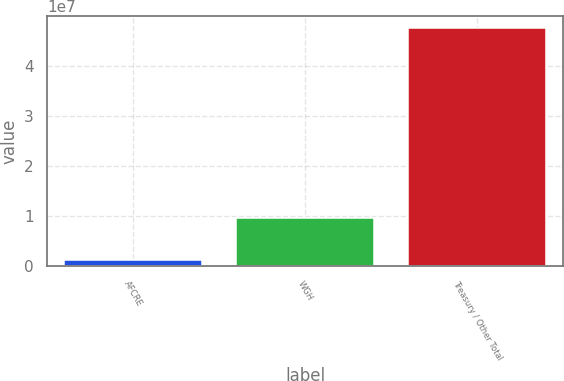Convert chart. <chart><loc_0><loc_0><loc_500><loc_500><bar_chart><fcel>AFCRE<fcel>WGH<fcel>Treasury / Other Total<nl><fcel>1.16364e+06<fcel>9.65717e+06<fcel>4.75067e+07<nl></chart> 